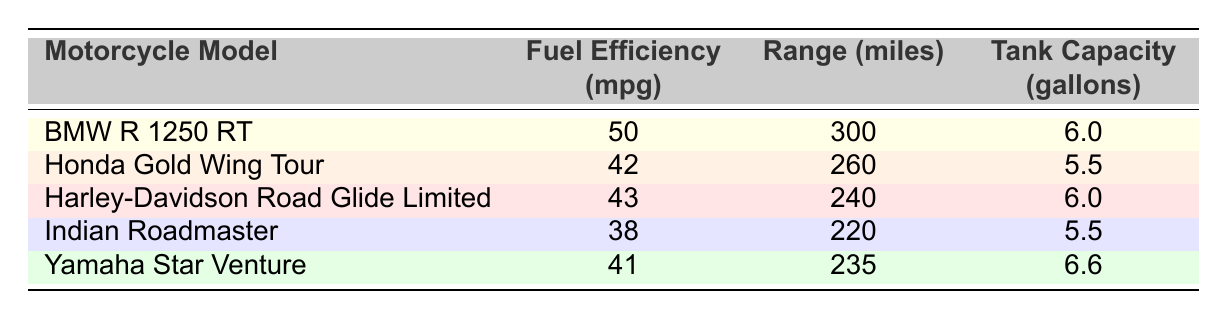What's the fuel efficiency of the BMW R 1250 RT? The table lists the fuel efficiency for each motorcycle model. For the BMW R 1250 RT, the fuel efficiency is directly provided as 50 miles per gallon.
Answer: 50 mpg Which motorcycle has the highest range? To find the highest range, I look at the range column. The BMW R 1250 RT has the highest range at 300 miles compared to the other models listed.
Answer: BMW R 1250 RT Is the fuel efficiency of the Honda Gold Wing Tour greater than 40 mpg? I check the fuel efficiency of the Honda Gold Wing Tour listed in the table, which is 42 mpg. Since 42 is greater than 40, the answer is yes.
Answer: Yes What is the total tank capacity of the Harley-Davidson Road Glide Limited and the Indian Roadmaster combined? I add the tank capacities of both motorcycles. The Harley-Davidson Road Glide Limited has a tank capacity of 6.0 gallons, and the Indian Roadmaster has 5.5 gallons. So, 6.0 + 5.5 = 11.5 gallons.
Answer: 11.5 gallons Which motorcycle has lower fuel efficiency: Yamaha Star Venture or Indian Roadmaster? I compare the fuel efficiencies: Yamaha Star Venture has 41 mpg and Indian Roadmaster has 38 mpg. Since 38 mpg is lower than 41 mpg, the Indian Roadmaster has lower fuel efficiency.
Answer: Indian Roadmaster What is the average fuel efficiency of the top 5 motorcycles? To find the average, I add the fuel efficiencies: 50 + 42 + 43 + 38 + 41 = 214 mpg. Then, divide by the number of motorcycles, which is 5. So, 214/5 = 42.8 mpg.
Answer: 42.8 mpg Does the Harley-Davidson Road Glide Limited have a higher range than the Yamaha Star Venture? I compare the range values: Harley-Davidson Road Glide Limited has 240 miles while Yamaha Star Venture has 235 miles. Since 240 is higher than 235, the answer is yes.
Answer: Yes Which motorcycle has a tank capacity of 5.5 gallons? I check the tank capacity of each motorcycle listed in the table. The Honda Gold Wing Tour and Indian Roadmaster both have a tank capacity of 5.5 gallons.
Answer: Honda Gold Wing Tour and Indian Roadmaster 